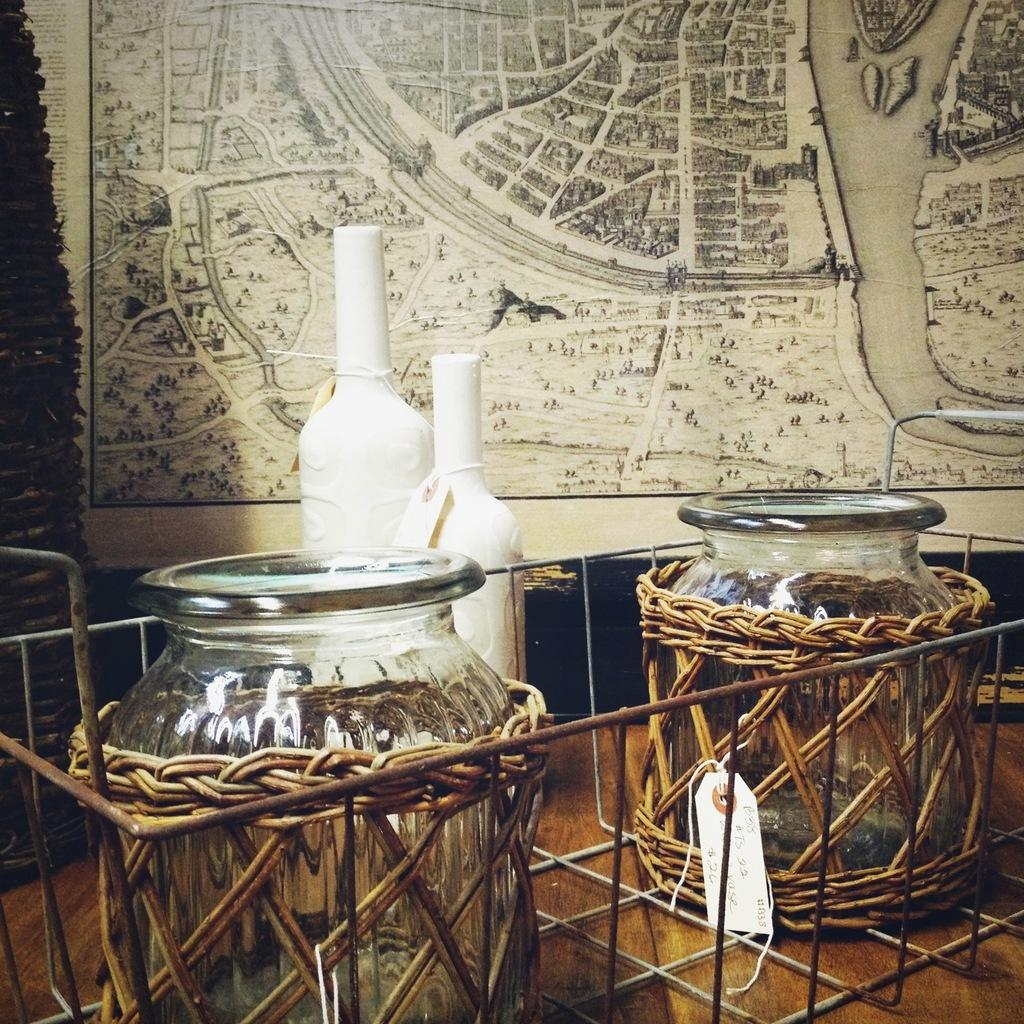What are the jars in the image made of? The jars in the image are made of glass. How are the glass jars arranged or held in the image? The jars are kept in a metal basket. What other items can be seen in the background of the image? There are bottles and a map in the background of the image. Can you describe the texture or background of the image? The image appears to have a cloth-like texture or background. What type of plastic cannon is visible in the image? There is no plastic cannon present in the image. What is the jars learning about in the image? The jars are not capable of learning, as they are inanimate objects. 